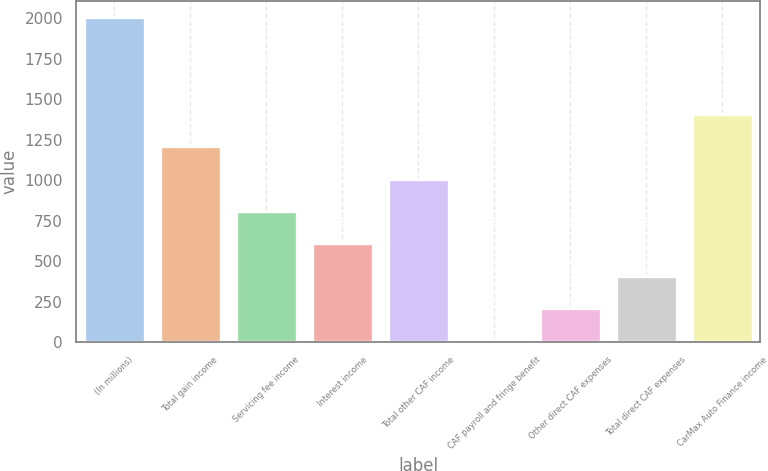Convert chart to OTSL. <chart><loc_0><loc_0><loc_500><loc_500><bar_chart><fcel>(In millions)<fcel>Total gain income<fcel>Servicing fee income<fcel>Interest income<fcel>Total other CAF income<fcel>CAF payroll and fringe benefit<fcel>Other direct CAF expenses<fcel>Total direct CAF expenses<fcel>CarMax Auto Finance income<nl><fcel>2007<fcel>1209<fcel>810<fcel>610.5<fcel>1009.5<fcel>12<fcel>211.5<fcel>411<fcel>1408.5<nl></chart> 